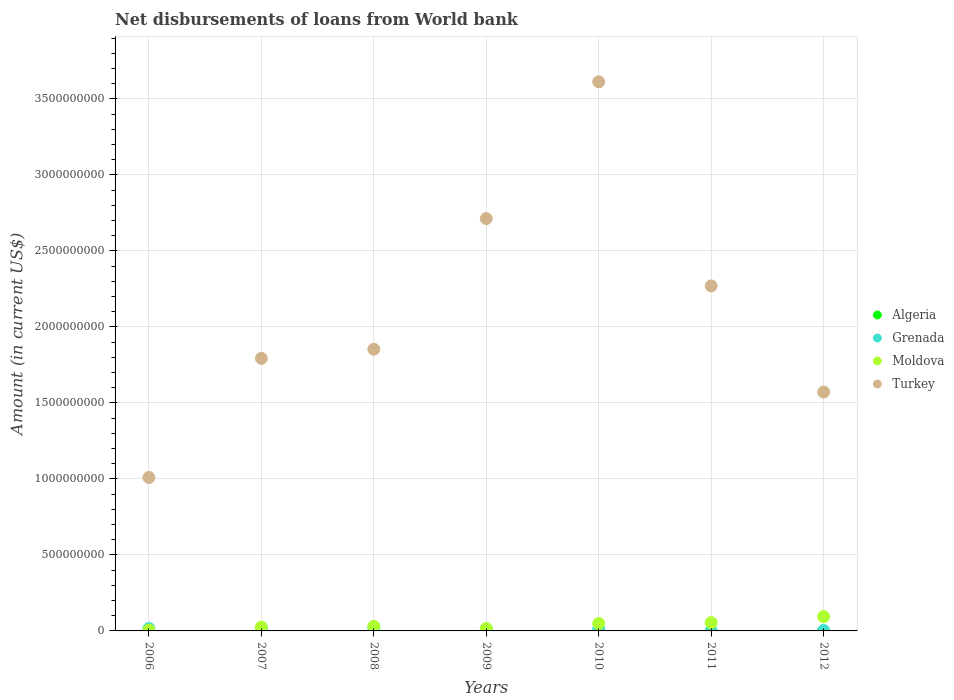Is the number of dotlines equal to the number of legend labels?
Ensure brevity in your answer.  No. What is the amount of loan disbursed from World Bank in Turkey in 2009?
Your answer should be compact. 2.71e+09. Across all years, what is the maximum amount of loan disbursed from World Bank in Grenada?
Give a very brief answer. 2.07e+07. In which year was the amount of loan disbursed from World Bank in Moldova maximum?
Your answer should be compact. 2012. What is the total amount of loan disbursed from World Bank in Grenada in the graph?
Your answer should be compact. 8.45e+07. What is the difference between the amount of loan disbursed from World Bank in Grenada in 2008 and that in 2012?
Provide a short and direct response. 1.78e+07. What is the difference between the amount of loan disbursed from World Bank in Moldova in 2011 and the amount of loan disbursed from World Bank in Grenada in 2009?
Provide a succinct answer. 4.21e+07. What is the average amount of loan disbursed from World Bank in Algeria per year?
Offer a very short reply. 0. In the year 2010, what is the difference between the amount of loan disbursed from World Bank in Grenada and amount of loan disbursed from World Bank in Turkey?
Offer a terse response. -3.60e+09. What is the ratio of the amount of loan disbursed from World Bank in Grenada in 2008 to that in 2010?
Make the answer very short. 1.54. Is the amount of loan disbursed from World Bank in Turkey in 2006 less than that in 2011?
Provide a short and direct response. Yes. Is the difference between the amount of loan disbursed from World Bank in Grenada in 2006 and 2009 greater than the difference between the amount of loan disbursed from World Bank in Turkey in 2006 and 2009?
Give a very brief answer. Yes. What is the difference between the highest and the second highest amount of loan disbursed from World Bank in Grenada?
Ensure brevity in your answer.  1.84e+06. What is the difference between the highest and the lowest amount of loan disbursed from World Bank in Grenada?
Make the answer very short. 2.07e+07. In how many years, is the amount of loan disbursed from World Bank in Moldova greater than the average amount of loan disbursed from World Bank in Moldova taken over all years?
Make the answer very short. 3. Is it the case that in every year, the sum of the amount of loan disbursed from World Bank in Algeria and amount of loan disbursed from World Bank in Grenada  is greater than the amount of loan disbursed from World Bank in Moldova?
Offer a terse response. No. How many dotlines are there?
Ensure brevity in your answer.  3. Does the graph contain any zero values?
Provide a succinct answer. Yes. Does the graph contain grids?
Ensure brevity in your answer.  Yes. How many legend labels are there?
Your answer should be compact. 4. How are the legend labels stacked?
Your answer should be very brief. Vertical. What is the title of the graph?
Provide a succinct answer. Net disbursements of loans from World bank. What is the Amount (in current US$) in Grenada in 2006?
Offer a very short reply. 1.61e+07. What is the Amount (in current US$) of Moldova in 2006?
Offer a terse response. 5.95e+06. What is the Amount (in current US$) in Turkey in 2006?
Your response must be concise. 1.01e+09. What is the Amount (in current US$) of Algeria in 2007?
Your answer should be very brief. 0. What is the Amount (in current US$) in Grenada in 2007?
Make the answer very short. 1.88e+07. What is the Amount (in current US$) in Moldova in 2007?
Offer a terse response. 2.53e+07. What is the Amount (in current US$) of Turkey in 2007?
Keep it short and to the point. 1.79e+09. What is the Amount (in current US$) of Grenada in 2008?
Ensure brevity in your answer.  2.07e+07. What is the Amount (in current US$) in Moldova in 2008?
Make the answer very short. 3.04e+07. What is the Amount (in current US$) in Turkey in 2008?
Ensure brevity in your answer.  1.85e+09. What is the Amount (in current US$) in Algeria in 2009?
Make the answer very short. 0. What is the Amount (in current US$) in Grenada in 2009?
Keep it short and to the point. 1.27e+07. What is the Amount (in current US$) of Moldova in 2009?
Your answer should be compact. 1.61e+07. What is the Amount (in current US$) in Turkey in 2009?
Your answer should be compact. 2.71e+09. What is the Amount (in current US$) of Algeria in 2010?
Make the answer very short. 0. What is the Amount (in current US$) of Grenada in 2010?
Your response must be concise. 1.34e+07. What is the Amount (in current US$) of Moldova in 2010?
Your answer should be compact. 4.88e+07. What is the Amount (in current US$) in Turkey in 2010?
Offer a very short reply. 3.61e+09. What is the Amount (in current US$) of Algeria in 2011?
Provide a short and direct response. 0. What is the Amount (in current US$) of Grenada in 2011?
Offer a terse response. 0. What is the Amount (in current US$) in Moldova in 2011?
Your answer should be very brief. 5.47e+07. What is the Amount (in current US$) of Turkey in 2011?
Your response must be concise. 2.27e+09. What is the Amount (in current US$) in Algeria in 2012?
Offer a very short reply. 0. What is the Amount (in current US$) of Grenada in 2012?
Give a very brief answer. 2.82e+06. What is the Amount (in current US$) of Moldova in 2012?
Provide a succinct answer. 9.39e+07. What is the Amount (in current US$) in Turkey in 2012?
Your answer should be very brief. 1.57e+09. Across all years, what is the maximum Amount (in current US$) of Grenada?
Offer a very short reply. 2.07e+07. Across all years, what is the maximum Amount (in current US$) of Moldova?
Give a very brief answer. 9.39e+07. Across all years, what is the maximum Amount (in current US$) in Turkey?
Provide a succinct answer. 3.61e+09. Across all years, what is the minimum Amount (in current US$) in Grenada?
Provide a short and direct response. 0. Across all years, what is the minimum Amount (in current US$) of Moldova?
Provide a short and direct response. 5.95e+06. Across all years, what is the minimum Amount (in current US$) of Turkey?
Offer a very short reply. 1.01e+09. What is the total Amount (in current US$) in Algeria in the graph?
Your response must be concise. 0. What is the total Amount (in current US$) of Grenada in the graph?
Offer a very short reply. 8.45e+07. What is the total Amount (in current US$) in Moldova in the graph?
Your answer should be very brief. 2.75e+08. What is the total Amount (in current US$) of Turkey in the graph?
Your response must be concise. 1.48e+1. What is the difference between the Amount (in current US$) of Grenada in 2006 and that in 2007?
Your answer should be compact. -2.72e+06. What is the difference between the Amount (in current US$) in Moldova in 2006 and that in 2007?
Offer a terse response. -1.94e+07. What is the difference between the Amount (in current US$) of Turkey in 2006 and that in 2007?
Your answer should be very brief. -7.84e+08. What is the difference between the Amount (in current US$) of Grenada in 2006 and that in 2008?
Your response must be concise. -4.55e+06. What is the difference between the Amount (in current US$) of Moldova in 2006 and that in 2008?
Keep it short and to the point. -2.45e+07. What is the difference between the Amount (in current US$) in Turkey in 2006 and that in 2008?
Provide a short and direct response. -8.44e+08. What is the difference between the Amount (in current US$) of Grenada in 2006 and that in 2009?
Your answer should be very brief. 3.43e+06. What is the difference between the Amount (in current US$) in Moldova in 2006 and that in 2009?
Provide a short and direct response. -1.01e+07. What is the difference between the Amount (in current US$) in Turkey in 2006 and that in 2009?
Provide a succinct answer. -1.70e+09. What is the difference between the Amount (in current US$) of Grenada in 2006 and that in 2010?
Your answer should be compact. 2.68e+06. What is the difference between the Amount (in current US$) of Moldova in 2006 and that in 2010?
Provide a succinct answer. -4.28e+07. What is the difference between the Amount (in current US$) of Turkey in 2006 and that in 2010?
Offer a very short reply. -2.60e+09. What is the difference between the Amount (in current US$) in Moldova in 2006 and that in 2011?
Ensure brevity in your answer.  -4.88e+07. What is the difference between the Amount (in current US$) of Turkey in 2006 and that in 2011?
Offer a terse response. -1.26e+09. What is the difference between the Amount (in current US$) of Grenada in 2006 and that in 2012?
Ensure brevity in your answer.  1.33e+07. What is the difference between the Amount (in current US$) of Moldova in 2006 and that in 2012?
Offer a terse response. -8.80e+07. What is the difference between the Amount (in current US$) in Turkey in 2006 and that in 2012?
Keep it short and to the point. -5.62e+08. What is the difference between the Amount (in current US$) in Grenada in 2007 and that in 2008?
Provide a short and direct response. -1.84e+06. What is the difference between the Amount (in current US$) of Moldova in 2007 and that in 2008?
Your response must be concise. -5.12e+06. What is the difference between the Amount (in current US$) in Turkey in 2007 and that in 2008?
Provide a succinct answer. -6.01e+07. What is the difference between the Amount (in current US$) of Grenada in 2007 and that in 2009?
Give a very brief answer. 6.15e+06. What is the difference between the Amount (in current US$) in Moldova in 2007 and that in 2009?
Your response must be concise. 9.24e+06. What is the difference between the Amount (in current US$) of Turkey in 2007 and that in 2009?
Give a very brief answer. -9.20e+08. What is the difference between the Amount (in current US$) in Grenada in 2007 and that in 2010?
Your answer should be very brief. 5.40e+06. What is the difference between the Amount (in current US$) of Moldova in 2007 and that in 2010?
Ensure brevity in your answer.  -2.35e+07. What is the difference between the Amount (in current US$) in Turkey in 2007 and that in 2010?
Keep it short and to the point. -1.82e+09. What is the difference between the Amount (in current US$) of Moldova in 2007 and that in 2011?
Keep it short and to the point. -2.94e+07. What is the difference between the Amount (in current US$) of Turkey in 2007 and that in 2011?
Give a very brief answer. -4.77e+08. What is the difference between the Amount (in current US$) of Grenada in 2007 and that in 2012?
Offer a terse response. 1.60e+07. What is the difference between the Amount (in current US$) of Moldova in 2007 and that in 2012?
Give a very brief answer. -6.86e+07. What is the difference between the Amount (in current US$) of Turkey in 2007 and that in 2012?
Provide a short and direct response. 2.22e+08. What is the difference between the Amount (in current US$) in Grenada in 2008 and that in 2009?
Give a very brief answer. 7.99e+06. What is the difference between the Amount (in current US$) of Moldova in 2008 and that in 2009?
Your answer should be compact. 1.44e+07. What is the difference between the Amount (in current US$) in Turkey in 2008 and that in 2009?
Your answer should be very brief. -8.60e+08. What is the difference between the Amount (in current US$) in Grenada in 2008 and that in 2010?
Offer a very short reply. 7.23e+06. What is the difference between the Amount (in current US$) in Moldova in 2008 and that in 2010?
Offer a very short reply. -1.83e+07. What is the difference between the Amount (in current US$) of Turkey in 2008 and that in 2010?
Provide a succinct answer. -1.76e+09. What is the difference between the Amount (in current US$) of Moldova in 2008 and that in 2011?
Offer a terse response. -2.43e+07. What is the difference between the Amount (in current US$) of Turkey in 2008 and that in 2011?
Make the answer very short. -4.17e+08. What is the difference between the Amount (in current US$) of Grenada in 2008 and that in 2012?
Provide a short and direct response. 1.78e+07. What is the difference between the Amount (in current US$) of Moldova in 2008 and that in 2012?
Give a very brief answer. -6.35e+07. What is the difference between the Amount (in current US$) in Turkey in 2008 and that in 2012?
Give a very brief answer. 2.82e+08. What is the difference between the Amount (in current US$) of Grenada in 2009 and that in 2010?
Ensure brevity in your answer.  -7.53e+05. What is the difference between the Amount (in current US$) in Moldova in 2009 and that in 2010?
Give a very brief answer. -3.27e+07. What is the difference between the Amount (in current US$) in Turkey in 2009 and that in 2010?
Ensure brevity in your answer.  -9.00e+08. What is the difference between the Amount (in current US$) of Moldova in 2009 and that in 2011?
Keep it short and to the point. -3.87e+07. What is the difference between the Amount (in current US$) in Turkey in 2009 and that in 2011?
Keep it short and to the point. 4.43e+08. What is the difference between the Amount (in current US$) of Grenada in 2009 and that in 2012?
Your response must be concise. 9.84e+06. What is the difference between the Amount (in current US$) in Moldova in 2009 and that in 2012?
Give a very brief answer. -7.78e+07. What is the difference between the Amount (in current US$) in Turkey in 2009 and that in 2012?
Offer a very short reply. 1.14e+09. What is the difference between the Amount (in current US$) of Moldova in 2010 and that in 2011?
Your response must be concise. -5.98e+06. What is the difference between the Amount (in current US$) of Turkey in 2010 and that in 2011?
Your answer should be very brief. 1.34e+09. What is the difference between the Amount (in current US$) of Grenada in 2010 and that in 2012?
Offer a terse response. 1.06e+07. What is the difference between the Amount (in current US$) of Moldova in 2010 and that in 2012?
Ensure brevity in your answer.  -4.52e+07. What is the difference between the Amount (in current US$) in Turkey in 2010 and that in 2012?
Provide a succinct answer. 2.04e+09. What is the difference between the Amount (in current US$) in Moldova in 2011 and that in 2012?
Offer a very short reply. -3.92e+07. What is the difference between the Amount (in current US$) in Turkey in 2011 and that in 2012?
Keep it short and to the point. 6.99e+08. What is the difference between the Amount (in current US$) of Grenada in 2006 and the Amount (in current US$) of Moldova in 2007?
Provide a succinct answer. -9.21e+06. What is the difference between the Amount (in current US$) of Grenada in 2006 and the Amount (in current US$) of Turkey in 2007?
Your answer should be compact. -1.78e+09. What is the difference between the Amount (in current US$) of Moldova in 2006 and the Amount (in current US$) of Turkey in 2007?
Ensure brevity in your answer.  -1.79e+09. What is the difference between the Amount (in current US$) in Grenada in 2006 and the Amount (in current US$) in Moldova in 2008?
Keep it short and to the point. -1.43e+07. What is the difference between the Amount (in current US$) in Grenada in 2006 and the Amount (in current US$) in Turkey in 2008?
Your answer should be compact. -1.84e+09. What is the difference between the Amount (in current US$) in Moldova in 2006 and the Amount (in current US$) in Turkey in 2008?
Your answer should be compact. -1.85e+09. What is the difference between the Amount (in current US$) in Grenada in 2006 and the Amount (in current US$) in Turkey in 2009?
Keep it short and to the point. -2.70e+09. What is the difference between the Amount (in current US$) in Moldova in 2006 and the Amount (in current US$) in Turkey in 2009?
Your answer should be very brief. -2.71e+09. What is the difference between the Amount (in current US$) in Grenada in 2006 and the Amount (in current US$) in Moldova in 2010?
Your response must be concise. -3.27e+07. What is the difference between the Amount (in current US$) in Grenada in 2006 and the Amount (in current US$) in Turkey in 2010?
Your answer should be very brief. -3.60e+09. What is the difference between the Amount (in current US$) of Moldova in 2006 and the Amount (in current US$) of Turkey in 2010?
Ensure brevity in your answer.  -3.61e+09. What is the difference between the Amount (in current US$) in Grenada in 2006 and the Amount (in current US$) in Moldova in 2011?
Provide a succinct answer. -3.86e+07. What is the difference between the Amount (in current US$) of Grenada in 2006 and the Amount (in current US$) of Turkey in 2011?
Provide a succinct answer. -2.25e+09. What is the difference between the Amount (in current US$) in Moldova in 2006 and the Amount (in current US$) in Turkey in 2011?
Your response must be concise. -2.26e+09. What is the difference between the Amount (in current US$) of Grenada in 2006 and the Amount (in current US$) of Moldova in 2012?
Your answer should be very brief. -7.78e+07. What is the difference between the Amount (in current US$) in Grenada in 2006 and the Amount (in current US$) in Turkey in 2012?
Keep it short and to the point. -1.56e+09. What is the difference between the Amount (in current US$) of Moldova in 2006 and the Amount (in current US$) of Turkey in 2012?
Make the answer very short. -1.57e+09. What is the difference between the Amount (in current US$) of Grenada in 2007 and the Amount (in current US$) of Moldova in 2008?
Your answer should be compact. -1.16e+07. What is the difference between the Amount (in current US$) of Grenada in 2007 and the Amount (in current US$) of Turkey in 2008?
Your response must be concise. -1.83e+09. What is the difference between the Amount (in current US$) in Moldova in 2007 and the Amount (in current US$) in Turkey in 2008?
Offer a very short reply. -1.83e+09. What is the difference between the Amount (in current US$) of Grenada in 2007 and the Amount (in current US$) of Moldova in 2009?
Ensure brevity in your answer.  2.74e+06. What is the difference between the Amount (in current US$) of Grenada in 2007 and the Amount (in current US$) of Turkey in 2009?
Provide a short and direct response. -2.69e+09. What is the difference between the Amount (in current US$) of Moldova in 2007 and the Amount (in current US$) of Turkey in 2009?
Keep it short and to the point. -2.69e+09. What is the difference between the Amount (in current US$) in Grenada in 2007 and the Amount (in current US$) in Moldova in 2010?
Offer a very short reply. -3.00e+07. What is the difference between the Amount (in current US$) of Grenada in 2007 and the Amount (in current US$) of Turkey in 2010?
Make the answer very short. -3.59e+09. What is the difference between the Amount (in current US$) in Moldova in 2007 and the Amount (in current US$) in Turkey in 2010?
Keep it short and to the point. -3.59e+09. What is the difference between the Amount (in current US$) in Grenada in 2007 and the Amount (in current US$) in Moldova in 2011?
Your response must be concise. -3.59e+07. What is the difference between the Amount (in current US$) in Grenada in 2007 and the Amount (in current US$) in Turkey in 2011?
Ensure brevity in your answer.  -2.25e+09. What is the difference between the Amount (in current US$) in Moldova in 2007 and the Amount (in current US$) in Turkey in 2011?
Your answer should be compact. -2.24e+09. What is the difference between the Amount (in current US$) of Grenada in 2007 and the Amount (in current US$) of Moldova in 2012?
Provide a succinct answer. -7.51e+07. What is the difference between the Amount (in current US$) of Grenada in 2007 and the Amount (in current US$) of Turkey in 2012?
Give a very brief answer. -1.55e+09. What is the difference between the Amount (in current US$) in Moldova in 2007 and the Amount (in current US$) in Turkey in 2012?
Offer a very short reply. -1.55e+09. What is the difference between the Amount (in current US$) in Grenada in 2008 and the Amount (in current US$) in Moldova in 2009?
Offer a very short reply. 4.58e+06. What is the difference between the Amount (in current US$) of Grenada in 2008 and the Amount (in current US$) of Turkey in 2009?
Provide a succinct answer. -2.69e+09. What is the difference between the Amount (in current US$) of Moldova in 2008 and the Amount (in current US$) of Turkey in 2009?
Provide a short and direct response. -2.68e+09. What is the difference between the Amount (in current US$) in Grenada in 2008 and the Amount (in current US$) in Moldova in 2010?
Offer a terse response. -2.81e+07. What is the difference between the Amount (in current US$) in Grenada in 2008 and the Amount (in current US$) in Turkey in 2010?
Provide a short and direct response. -3.59e+09. What is the difference between the Amount (in current US$) of Moldova in 2008 and the Amount (in current US$) of Turkey in 2010?
Give a very brief answer. -3.58e+09. What is the difference between the Amount (in current US$) in Grenada in 2008 and the Amount (in current US$) in Moldova in 2011?
Provide a short and direct response. -3.41e+07. What is the difference between the Amount (in current US$) of Grenada in 2008 and the Amount (in current US$) of Turkey in 2011?
Offer a terse response. -2.25e+09. What is the difference between the Amount (in current US$) of Moldova in 2008 and the Amount (in current US$) of Turkey in 2011?
Provide a succinct answer. -2.24e+09. What is the difference between the Amount (in current US$) in Grenada in 2008 and the Amount (in current US$) in Moldova in 2012?
Offer a very short reply. -7.33e+07. What is the difference between the Amount (in current US$) in Grenada in 2008 and the Amount (in current US$) in Turkey in 2012?
Your answer should be very brief. -1.55e+09. What is the difference between the Amount (in current US$) of Moldova in 2008 and the Amount (in current US$) of Turkey in 2012?
Your answer should be very brief. -1.54e+09. What is the difference between the Amount (in current US$) in Grenada in 2009 and the Amount (in current US$) in Moldova in 2010?
Your answer should be compact. -3.61e+07. What is the difference between the Amount (in current US$) of Grenada in 2009 and the Amount (in current US$) of Turkey in 2010?
Your response must be concise. -3.60e+09. What is the difference between the Amount (in current US$) of Moldova in 2009 and the Amount (in current US$) of Turkey in 2010?
Ensure brevity in your answer.  -3.60e+09. What is the difference between the Amount (in current US$) of Grenada in 2009 and the Amount (in current US$) of Moldova in 2011?
Give a very brief answer. -4.21e+07. What is the difference between the Amount (in current US$) of Grenada in 2009 and the Amount (in current US$) of Turkey in 2011?
Your response must be concise. -2.26e+09. What is the difference between the Amount (in current US$) of Moldova in 2009 and the Amount (in current US$) of Turkey in 2011?
Give a very brief answer. -2.25e+09. What is the difference between the Amount (in current US$) of Grenada in 2009 and the Amount (in current US$) of Moldova in 2012?
Ensure brevity in your answer.  -8.13e+07. What is the difference between the Amount (in current US$) of Grenada in 2009 and the Amount (in current US$) of Turkey in 2012?
Your answer should be very brief. -1.56e+09. What is the difference between the Amount (in current US$) in Moldova in 2009 and the Amount (in current US$) in Turkey in 2012?
Provide a short and direct response. -1.56e+09. What is the difference between the Amount (in current US$) in Grenada in 2010 and the Amount (in current US$) in Moldova in 2011?
Keep it short and to the point. -4.13e+07. What is the difference between the Amount (in current US$) of Grenada in 2010 and the Amount (in current US$) of Turkey in 2011?
Your response must be concise. -2.26e+09. What is the difference between the Amount (in current US$) in Moldova in 2010 and the Amount (in current US$) in Turkey in 2011?
Make the answer very short. -2.22e+09. What is the difference between the Amount (in current US$) of Grenada in 2010 and the Amount (in current US$) of Moldova in 2012?
Keep it short and to the point. -8.05e+07. What is the difference between the Amount (in current US$) of Grenada in 2010 and the Amount (in current US$) of Turkey in 2012?
Make the answer very short. -1.56e+09. What is the difference between the Amount (in current US$) of Moldova in 2010 and the Amount (in current US$) of Turkey in 2012?
Ensure brevity in your answer.  -1.52e+09. What is the difference between the Amount (in current US$) of Moldova in 2011 and the Amount (in current US$) of Turkey in 2012?
Give a very brief answer. -1.52e+09. What is the average Amount (in current US$) in Algeria per year?
Your response must be concise. 0. What is the average Amount (in current US$) of Grenada per year?
Your answer should be compact. 1.21e+07. What is the average Amount (in current US$) in Moldova per year?
Provide a succinct answer. 3.93e+07. What is the average Amount (in current US$) of Turkey per year?
Your response must be concise. 2.12e+09. In the year 2006, what is the difference between the Amount (in current US$) in Grenada and Amount (in current US$) in Moldova?
Your answer should be compact. 1.01e+07. In the year 2006, what is the difference between the Amount (in current US$) in Grenada and Amount (in current US$) in Turkey?
Provide a short and direct response. -9.93e+08. In the year 2006, what is the difference between the Amount (in current US$) in Moldova and Amount (in current US$) in Turkey?
Your answer should be very brief. -1.00e+09. In the year 2007, what is the difference between the Amount (in current US$) of Grenada and Amount (in current US$) of Moldova?
Offer a terse response. -6.50e+06. In the year 2007, what is the difference between the Amount (in current US$) in Grenada and Amount (in current US$) in Turkey?
Offer a terse response. -1.77e+09. In the year 2007, what is the difference between the Amount (in current US$) in Moldova and Amount (in current US$) in Turkey?
Your answer should be compact. -1.77e+09. In the year 2008, what is the difference between the Amount (in current US$) of Grenada and Amount (in current US$) of Moldova?
Make the answer very short. -9.78e+06. In the year 2008, what is the difference between the Amount (in current US$) in Grenada and Amount (in current US$) in Turkey?
Provide a short and direct response. -1.83e+09. In the year 2008, what is the difference between the Amount (in current US$) of Moldova and Amount (in current US$) of Turkey?
Your answer should be very brief. -1.82e+09. In the year 2009, what is the difference between the Amount (in current US$) of Grenada and Amount (in current US$) of Moldova?
Give a very brief answer. -3.40e+06. In the year 2009, what is the difference between the Amount (in current US$) in Grenada and Amount (in current US$) in Turkey?
Your answer should be very brief. -2.70e+09. In the year 2009, what is the difference between the Amount (in current US$) in Moldova and Amount (in current US$) in Turkey?
Your response must be concise. -2.70e+09. In the year 2010, what is the difference between the Amount (in current US$) in Grenada and Amount (in current US$) in Moldova?
Offer a very short reply. -3.53e+07. In the year 2010, what is the difference between the Amount (in current US$) of Grenada and Amount (in current US$) of Turkey?
Provide a short and direct response. -3.60e+09. In the year 2010, what is the difference between the Amount (in current US$) in Moldova and Amount (in current US$) in Turkey?
Your answer should be compact. -3.56e+09. In the year 2011, what is the difference between the Amount (in current US$) in Moldova and Amount (in current US$) in Turkey?
Keep it short and to the point. -2.22e+09. In the year 2012, what is the difference between the Amount (in current US$) in Grenada and Amount (in current US$) in Moldova?
Your answer should be compact. -9.11e+07. In the year 2012, what is the difference between the Amount (in current US$) of Grenada and Amount (in current US$) of Turkey?
Your answer should be compact. -1.57e+09. In the year 2012, what is the difference between the Amount (in current US$) of Moldova and Amount (in current US$) of Turkey?
Ensure brevity in your answer.  -1.48e+09. What is the ratio of the Amount (in current US$) of Grenada in 2006 to that in 2007?
Offer a terse response. 0.86. What is the ratio of the Amount (in current US$) in Moldova in 2006 to that in 2007?
Make the answer very short. 0.24. What is the ratio of the Amount (in current US$) in Turkey in 2006 to that in 2007?
Offer a very short reply. 0.56. What is the ratio of the Amount (in current US$) in Grenada in 2006 to that in 2008?
Your answer should be very brief. 0.78. What is the ratio of the Amount (in current US$) of Moldova in 2006 to that in 2008?
Your answer should be compact. 0.2. What is the ratio of the Amount (in current US$) in Turkey in 2006 to that in 2008?
Offer a very short reply. 0.54. What is the ratio of the Amount (in current US$) in Grenada in 2006 to that in 2009?
Make the answer very short. 1.27. What is the ratio of the Amount (in current US$) in Moldova in 2006 to that in 2009?
Provide a succinct answer. 0.37. What is the ratio of the Amount (in current US$) in Turkey in 2006 to that in 2009?
Offer a very short reply. 0.37. What is the ratio of the Amount (in current US$) in Grenada in 2006 to that in 2010?
Your answer should be very brief. 1.2. What is the ratio of the Amount (in current US$) in Moldova in 2006 to that in 2010?
Make the answer very short. 0.12. What is the ratio of the Amount (in current US$) in Turkey in 2006 to that in 2010?
Keep it short and to the point. 0.28. What is the ratio of the Amount (in current US$) of Moldova in 2006 to that in 2011?
Your response must be concise. 0.11. What is the ratio of the Amount (in current US$) in Turkey in 2006 to that in 2011?
Ensure brevity in your answer.  0.44. What is the ratio of the Amount (in current US$) of Grenada in 2006 to that in 2012?
Offer a very short reply. 5.7. What is the ratio of the Amount (in current US$) of Moldova in 2006 to that in 2012?
Make the answer very short. 0.06. What is the ratio of the Amount (in current US$) in Turkey in 2006 to that in 2012?
Provide a succinct answer. 0.64. What is the ratio of the Amount (in current US$) in Grenada in 2007 to that in 2008?
Your answer should be very brief. 0.91. What is the ratio of the Amount (in current US$) in Moldova in 2007 to that in 2008?
Ensure brevity in your answer.  0.83. What is the ratio of the Amount (in current US$) of Turkey in 2007 to that in 2008?
Offer a terse response. 0.97. What is the ratio of the Amount (in current US$) in Grenada in 2007 to that in 2009?
Provide a succinct answer. 1.49. What is the ratio of the Amount (in current US$) of Moldova in 2007 to that in 2009?
Keep it short and to the point. 1.58. What is the ratio of the Amount (in current US$) in Turkey in 2007 to that in 2009?
Keep it short and to the point. 0.66. What is the ratio of the Amount (in current US$) of Grenada in 2007 to that in 2010?
Ensure brevity in your answer.  1.4. What is the ratio of the Amount (in current US$) of Moldova in 2007 to that in 2010?
Your answer should be very brief. 0.52. What is the ratio of the Amount (in current US$) in Turkey in 2007 to that in 2010?
Provide a short and direct response. 0.5. What is the ratio of the Amount (in current US$) in Moldova in 2007 to that in 2011?
Your response must be concise. 0.46. What is the ratio of the Amount (in current US$) of Turkey in 2007 to that in 2011?
Offer a very short reply. 0.79. What is the ratio of the Amount (in current US$) in Grenada in 2007 to that in 2012?
Provide a short and direct response. 6.66. What is the ratio of the Amount (in current US$) of Moldova in 2007 to that in 2012?
Provide a short and direct response. 0.27. What is the ratio of the Amount (in current US$) in Turkey in 2007 to that in 2012?
Your answer should be very brief. 1.14. What is the ratio of the Amount (in current US$) in Grenada in 2008 to that in 2009?
Provide a short and direct response. 1.63. What is the ratio of the Amount (in current US$) of Moldova in 2008 to that in 2009?
Offer a very short reply. 1.89. What is the ratio of the Amount (in current US$) in Turkey in 2008 to that in 2009?
Your answer should be very brief. 0.68. What is the ratio of the Amount (in current US$) of Grenada in 2008 to that in 2010?
Keep it short and to the point. 1.54. What is the ratio of the Amount (in current US$) in Moldova in 2008 to that in 2010?
Provide a short and direct response. 0.62. What is the ratio of the Amount (in current US$) in Turkey in 2008 to that in 2010?
Offer a very short reply. 0.51. What is the ratio of the Amount (in current US$) of Moldova in 2008 to that in 2011?
Offer a terse response. 0.56. What is the ratio of the Amount (in current US$) in Turkey in 2008 to that in 2011?
Keep it short and to the point. 0.82. What is the ratio of the Amount (in current US$) of Grenada in 2008 to that in 2012?
Offer a terse response. 7.31. What is the ratio of the Amount (in current US$) of Moldova in 2008 to that in 2012?
Your response must be concise. 0.32. What is the ratio of the Amount (in current US$) in Turkey in 2008 to that in 2012?
Your answer should be very brief. 1.18. What is the ratio of the Amount (in current US$) in Grenada in 2009 to that in 2010?
Keep it short and to the point. 0.94. What is the ratio of the Amount (in current US$) in Moldova in 2009 to that in 2010?
Offer a very short reply. 0.33. What is the ratio of the Amount (in current US$) in Turkey in 2009 to that in 2010?
Your response must be concise. 0.75. What is the ratio of the Amount (in current US$) in Moldova in 2009 to that in 2011?
Your response must be concise. 0.29. What is the ratio of the Amount (in current US$) in Turkey in 2009 to that in 2011?
Provide a short and direct response. 1.2. What is the ratio of the Amount (in current US$) of Grenada in 2009 to that in 2012?
Provide a short and direct response. 4.48. What is the ratio of the Amount (in current US$) in Moldova in 2009 to that in 2012?
Provide a succinct answer. 0.17. What is the ratio of the Amount (in current US$) in Turkey in 2009 to that in 2012?
Keep it short and to the point. 1.73. What is the ratio of the Amount (in current US$) of Moldova in 2010 to that in 2011?
Your response must be concise. 0.89. What is the ratio of the Amount (in current US$) of Turkey in 2010 to that in 2011?
Offer a terse response. 1.59. What is the ratio of the Amount (in current US$) in Grenada in 2010 to that in 2012?
Give a very brief answer. 4.75. What is the ratio of the Amount (in current US$) of Moldova in 2010 to that in 2012?
Your answer should be compact. 0.52. What is the ratio of the Amount (in current US$) in Turkey in 2010 to that in 2012?
Ensure brevity in your answer.  2.3. What is the ratio of the Amount (in current US$) in Moldova in 2011 to that in 2012?
Offer a very short reply. 0.58. What is the ratio of the Amount (in current US$) of Turkey in 2011 to that in 2012?
Offer a very short reply. 1.44. What is the difference between the highest and the second highest Amount (in current US$) in Grenada?
Give a very brief answer. 1.84e+06. What is the difference between the highest and the second highest Amount (in current US$) of Moldova?
Offer a very short reply. 3.92e+07. What is the difference between the highest and the second highest Amount (in current US$) in Turkey?
Offer a terse response. 9.00e+08. What is the difference between the highest and the lowest Amount (in current US$) of Grenada?
Ensure brevity in your answer.  2.07e+07. What is the difference between the highest and the lowest Amount (in current US$) of Moldova?
Make the answer very short. 8.80e+07. What is the difference between the highest and the lowest Amount (in current US$) of Turkey?
Offer a terse response. 2.60e+09. 